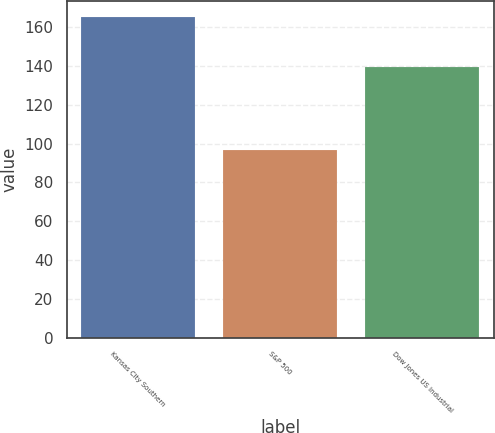<chart> <loc_0><loc_0><loc_500><loc_500><bar_chart><fcel>Kansas City Southern<fcel>S&P 500<fcel>Dow Jones US Industrial<nl><fcel>165.15<fcel>96.71<fcel>139.4<nl></chart> 